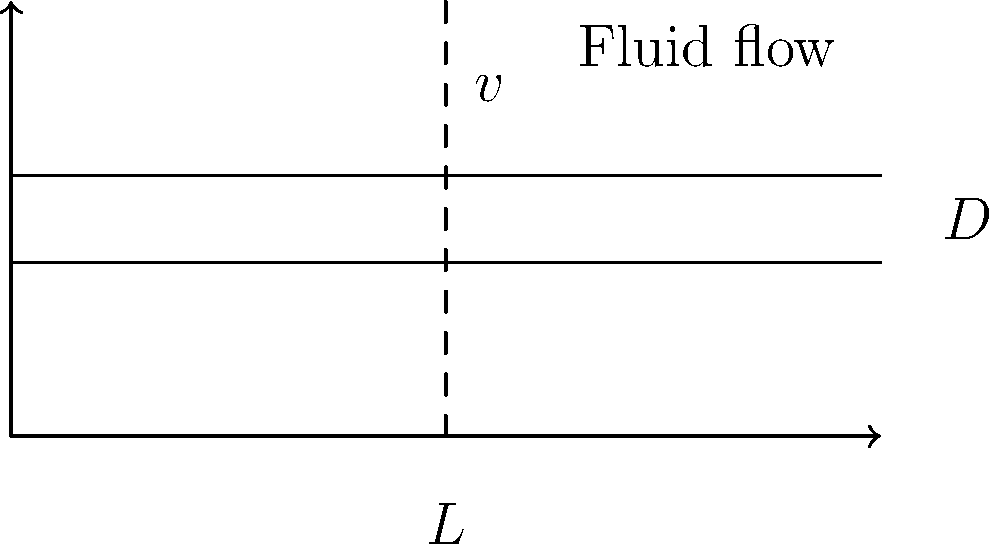A smooth pipe with a diameter $D = 0.05$ m and length $L = 10$ m is carrying water at 20°C. The average velocity of the water in the pipe is $v = 2$ m/s. Calculate the pressure drop along the pipe length. Assume the density of water $\rho = 998$ kg/m³ and its dynamic viscosity $\mu = 1.002 \times 10^{-3}$ Pa·s. To solve this problem, we'll follow these steps:

1) Calculate the Reynolds number (Re) to determine the flow regime:
   $$Re = \frac{\rho vD}{\mu}$$
   $$Re = \frac{998 \times 2 \times 0.05}{1.002 \times 10^{-3}} = 99,600$$
   This indicates turbulent flow (Re > 4000).

2) For turbulent flow in smooth pipes, we can use the Blasius equation to find the friction factor:
   $$f = \frac{0.316}{Re^{0.25}}$$
   $$f = \frac{0.316}{99,600^{0.25}} = 0.0181$$

3) Use the Darcy-Weisbach equation to calculate the pressure drop:
   $$\Delta P = f \frac{L}{D} \frac{\rho v^2}{2}$$

4) Substitute the values:
   $$\Delta P = 0.0181 \times \frac{10}{0.05} \times \frac{998 \times 2^2}{2}$$

5) Calculate the final result:
   $$\Delta P = 14,396 \text{ Pa} \approx 14.4 \text{ kPa}$$
Answer: 14.4 kPa 